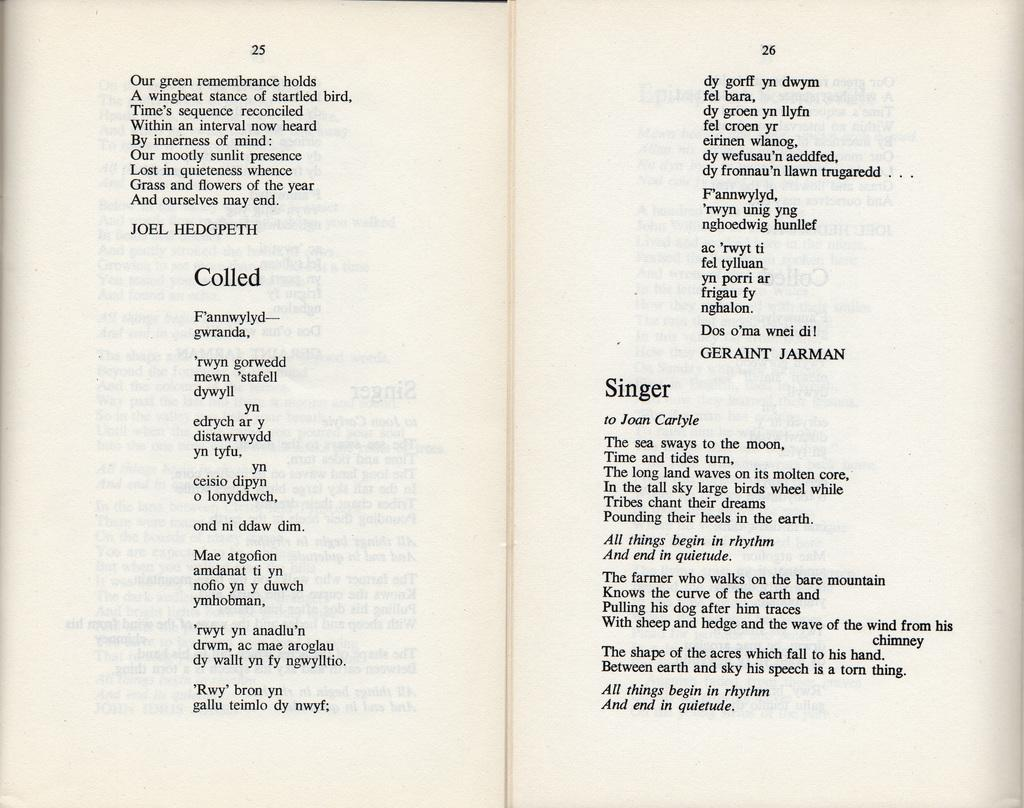<image>
Give a short and clear explanation of the subsequent image. A book is opened to page 25 and 26. 